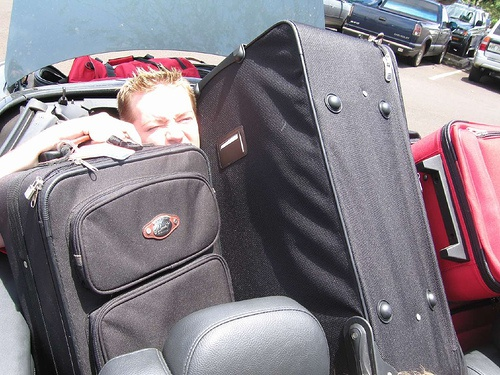Describe the objects in this image and their specific colors. I can see suitcase in ivory, black, darkgray, and gray tones, suitcase in ivory, gray, darkgray, and black tones, suitcase in ivory, lightpink, black, maroon, and pink tones, people in ivory, white, lightpink, tan, and brown tones, and truck in ivory, gray, darkgray, and black tones in this image. 